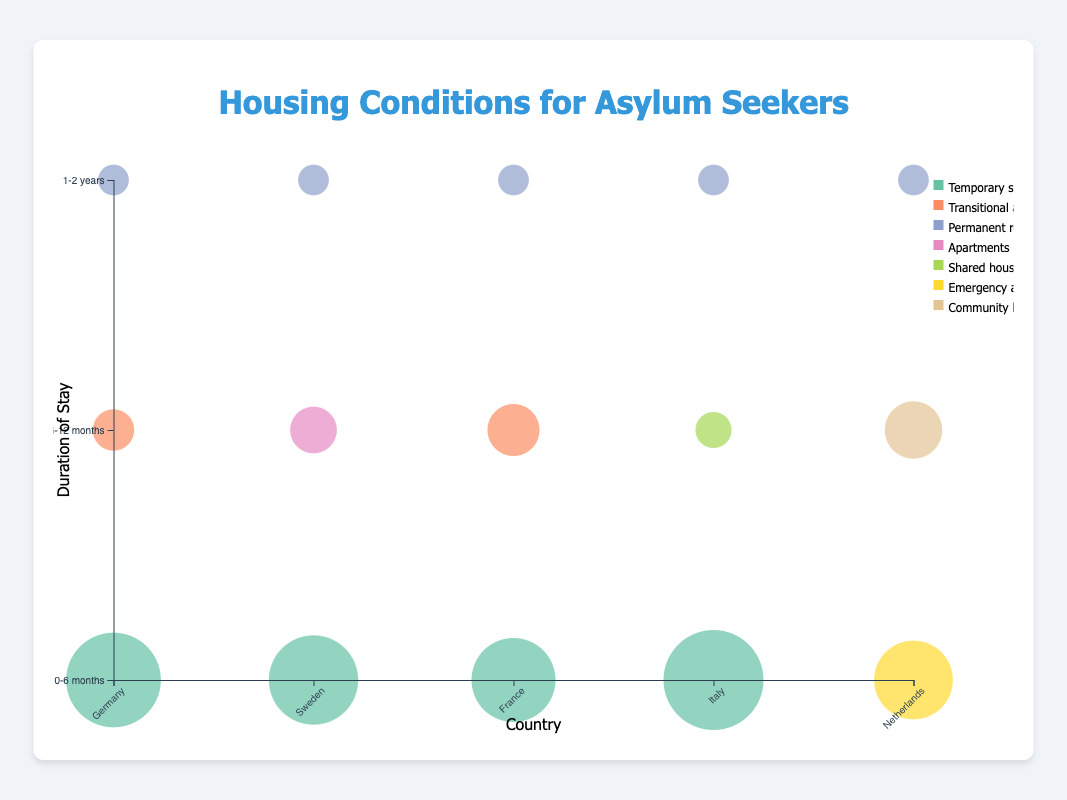What's the title of the figure? The title of the figure is displayed at the top center and reads "Housing Conditions for Asylum Seekers".
Answer: Housing Conditions for Asylum Seekers Which country has the highest percentage of asylum seekers in temporary shelters for 0-6 months? By looking at the bubble sizes at the "0-6 months" row, the bubble for Italy has the largest size, indicating it has the highest percentage of asylum seekers in temporary shelters.
Answer: Italy What housing type is represented by the largest bubble overall, and which country does it belong to? By comparing all the bubble sizes, the largest bubble indicates the highest percentage. The bubble size for "Temporary shelters" in Italy's "0-6 months" duration is the largest.
Answer: Temporary shelters, Italy Which country has the highest diversity of housing types? Count the unique housing types represented by different colored bubbles for each country. The country with the highest number of unique colors represents the most diverse housing types. Germany and Sweden both show three different types.
Answer: Germany and Sweden How does the distribution of housing types for asylum seekers in Germany change over time? By examining the vertical column for Germany, we see that initially, most asylum seekers are in "Temporary shelters" (largest bubble), then move to "Transitional accommodations" over time and finally to "Permanent residences".
Answer: Temporary shelters → Transitional accommodations → Permanent residences What is the dominant housing type for asylum seekers in the Netherlands for 6-12 months? By looking at the bubble in the "6-12 months" row for the Netherlands, the largest bubble size indicates the dominant housing type, which is "Community housing".
Answer: Community housing Compare the percentage of asylum seekers in transitional accommodations in Germany and France for 6-12 months. Compare the bubble sizes for "Transitional accommodations" in Germany and France in the "6-12 months" row. The bubble size indicates that Germany has 20% and France has 30%.
Answer: France (30%), Germany (20%) Which country shows a significant shift from temporary shelters to apartments within the first year? By analyzing the changes in bubble sizes and housing types within the first year for each country, we see that Sweden shows a significant shift from "Temporary shelters" to "Apartments".
Answer: Sweden What percentage of asylum seekers in France stay in transitional accommodations after 6-12 months? Look at the size of the bubble for France in the "6-12 months" duration that corresponds to "Transitional accommodations". The bubble represents 30%.
Answer: 30% Do any countries offer "Permanent residences" consistently after 1-2 years? Check the "1-2 years" row for countries with "Permanent residences" as the housing type. Each country (Germany, Sweden, France, Italy, Netherlands) shows a bubble for "Permanent residences".
Answer: Yes 